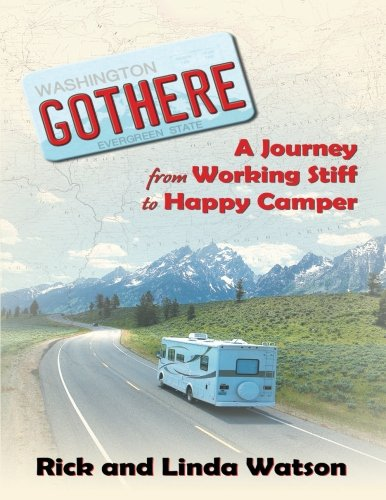What can be inferred about the book's setting from the cover image? The setting likely involves the Washington State, as indicated by the license plate tag 'Washington Evergreen State' on the RV, and the scenic backdrop that includes mountains and open roads, typical of this region's landscape. 